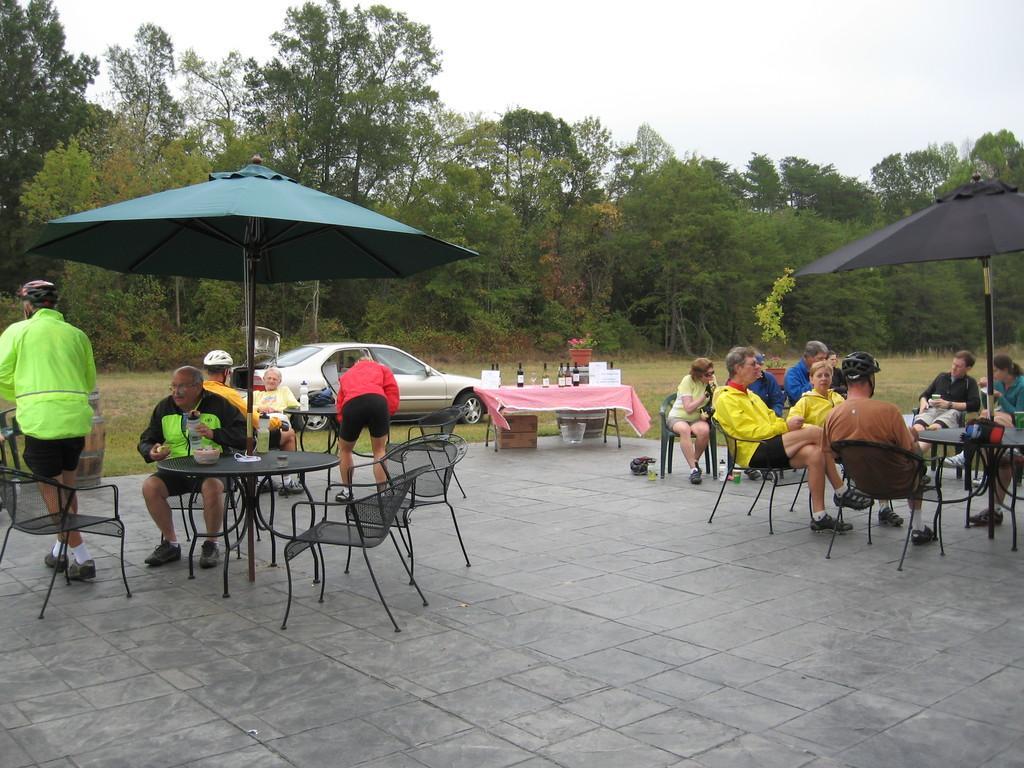Describe this image in one or two sentences. In the middle of the image there are few tables and chairs on the chairs few people are sitting. Behind them there is a car and grass. Top of the image there are some trees and clouds. 